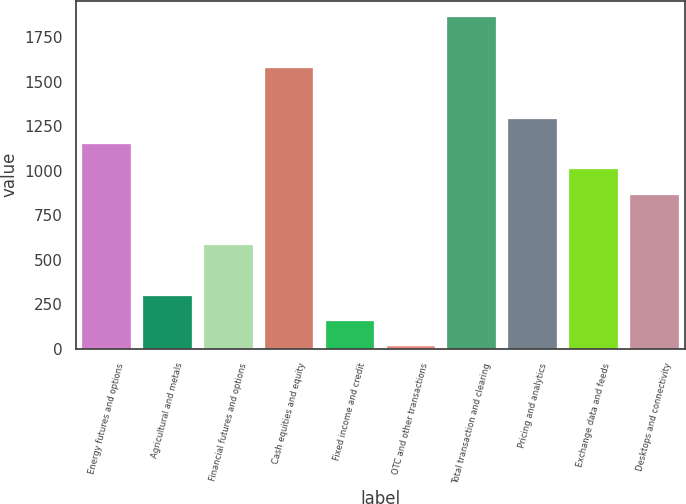Convert chart to OTSL. <chart><loc_0><loc_0><loc_500><loc_500><bar_chart><fcel>Energy futures and options<fcel>Agricultural and metals<fcel>Financial futures and options<fcel>Cash equities and equity<fcel>Fixed income and credit<fcel>OTC and other transactions<fcel>Total transaction and clearing<fcel>Pricing and analytics<fcel>Exchange data and feeds<fcel>Desktops and connectivity<nl><fcel>1150.4<fcel>296.6<fcel>581.2<fcel>1577.3<fcel>154.3<fcel>12<fcel>1861.9<fcel>1292.7<fcel>1008.1<fcel>865.8<nl></chart> 